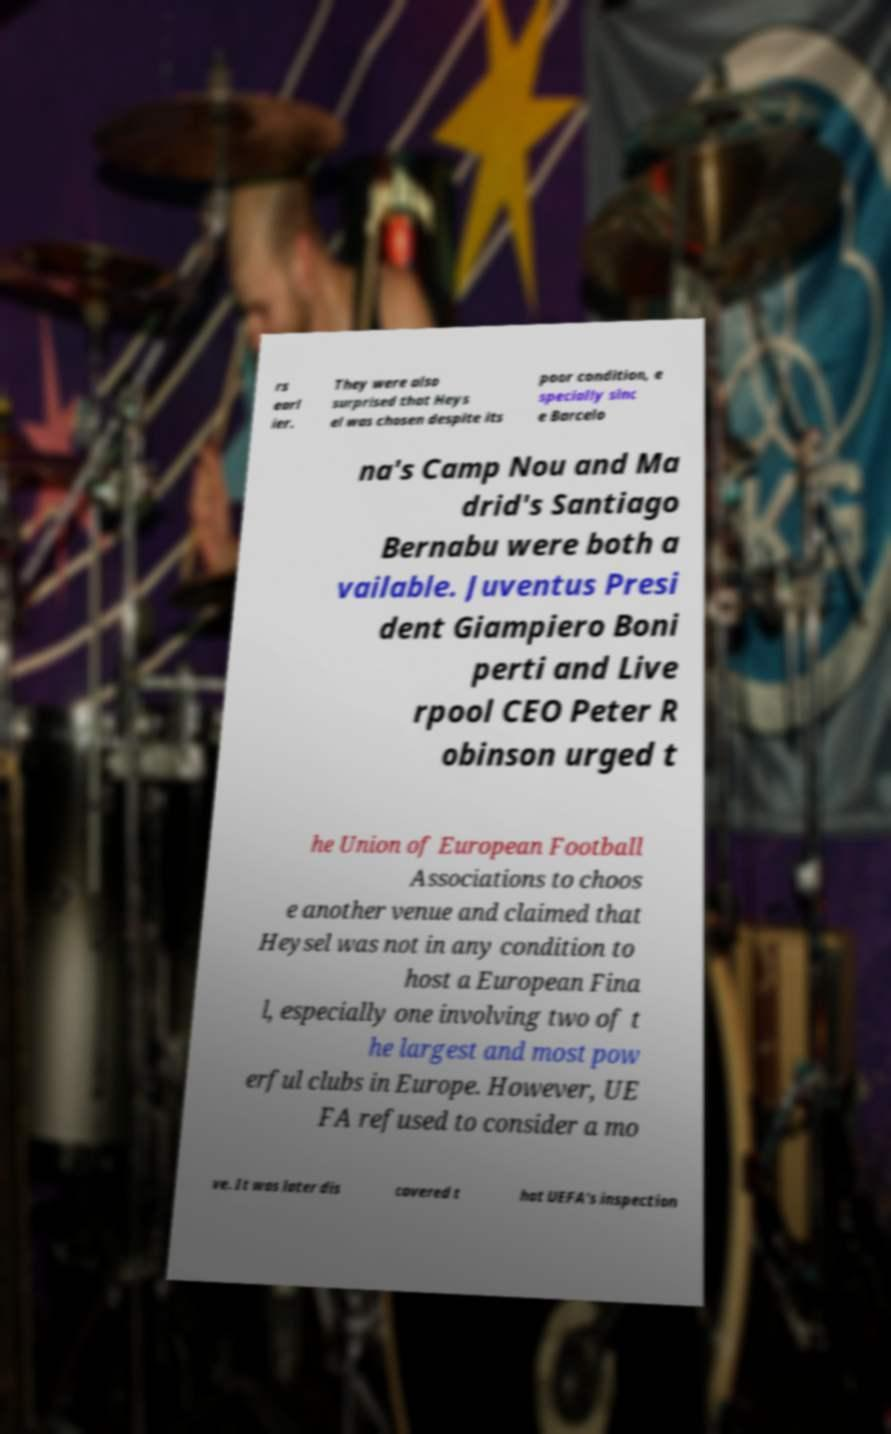There's text embedded in this image that I need extracted. Can you transcribe it verbatim? rs earl ier. They were also surprised that Heys el was chosen despite its poor condition, e specially sinc e Barcelo na's Camp Nou and Ma drid's Santiago Bernabu were both a vailable. Juventus Presi dent Giampiero Boni perti and Live rpool CEO Peter R obinson urged t he Union of European Football Associations to choos e another venue and claimed that Heysel was not in any condition to host a European Fina l, especially one involving two of t he largest and most pow erful clubs in Europe. However, UE FA refused to consider a mo ve. It was later dis covered t hat UEFA's inspection 